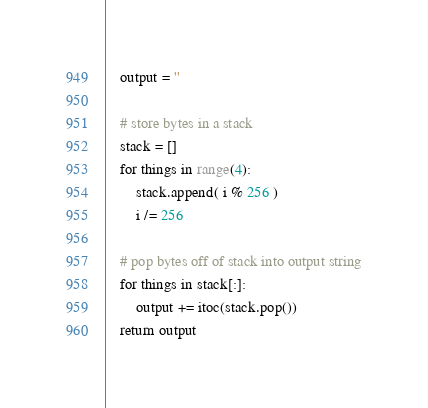<code> <loc_0><loc_0><loc_500><loc_500><_Python_>    output = ''
    
    # store bytes in a stack
    stack = []
    for things in range(4):
        stack.append( i % 256 )
        i /= 256

    # pop bytes off of stack into output string
    for things in stack[:]:
        output += itoc(stack.pop())
    return output
</code> 